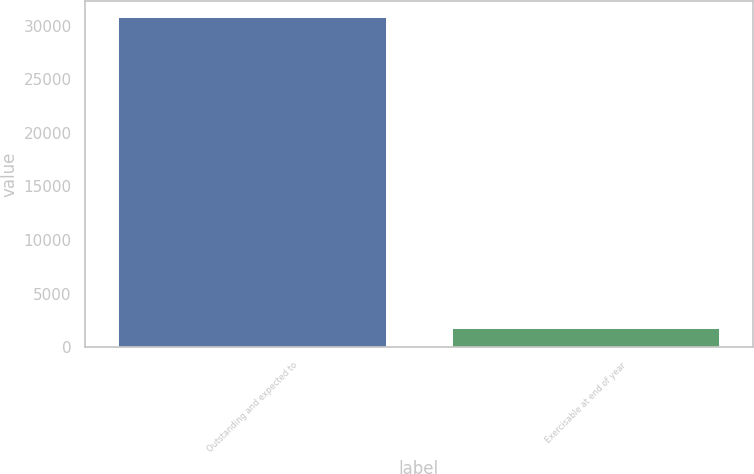Convert chart to OTSL. <chart><loc_0><loc_0><loc_500><loc_500><bar_chart><fcel>Outstanding and expected to<fcel>Exercisable at end of year<nl><fcel>30786<fcel>1798<nl></chart> 